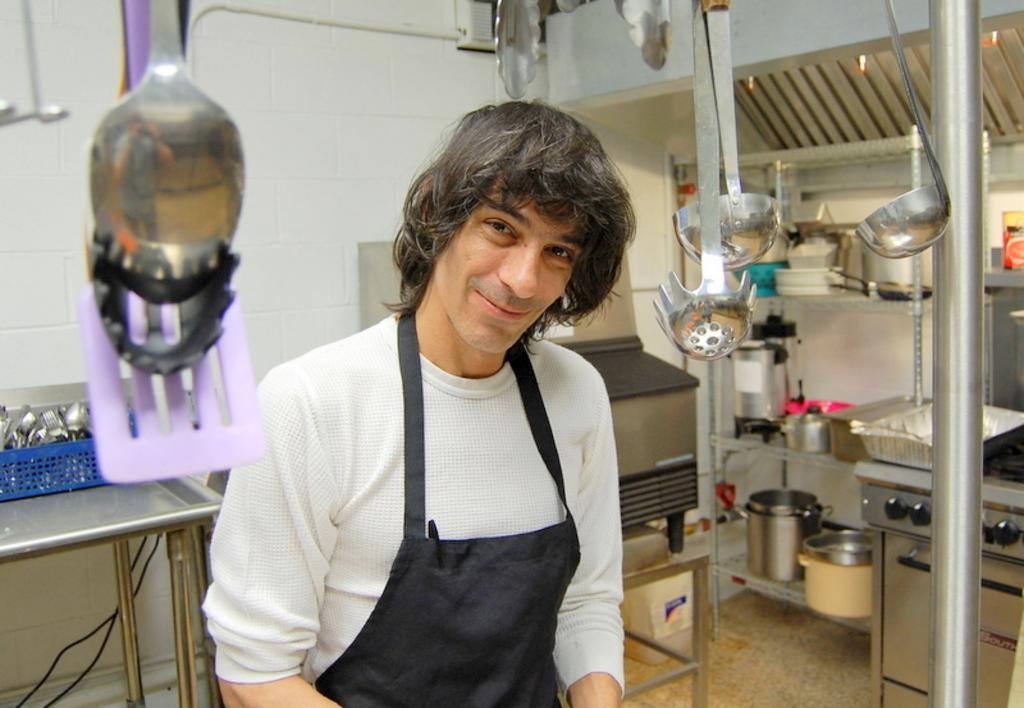Can you describe this image briefly? In this image I can see a person standing, the person is wearing black and white dress. Background I can see few utensils in the racks and I can see a table and the wall is in white color. 